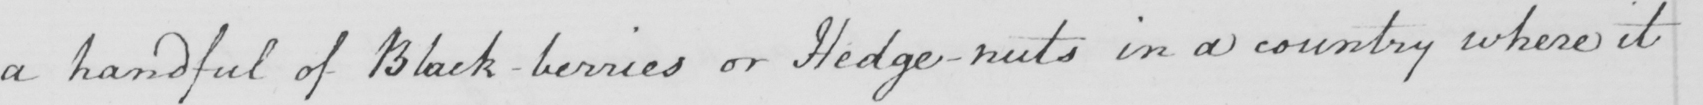What is written in this line of handwriting? a handful of Black-berries or Hedge-nuts in a country where it 